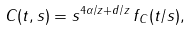<formula> <loc_0><loc_0><loc_500><loc_500>C ( t , s ) = s ^ { 4 \alpha / z + d / z } \, f _ { C } ( t / s ) ,</formula> 